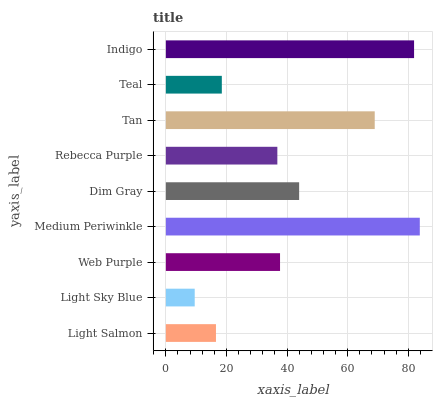Is Light Sky Blue the minimum?
Answer yes or no. Yes. Is Medium Periwinkle the maximum?
Answer yes or no. Yes. Is Web Purple the minimum?
Answer yes or no. No. Is Web Purple the maximum?
Answer yes or no. No. Is Web Purple greater than Light Sky Blue?
Answer yes or no. Yes. Is Light Sky Blue less than Web Purple?
Answer yes or no. Yes. Is Light Sky Blue greater than Web Purple?
Answer yes or no. No. Is Web Purple less than Light Sky Blue?
Answer yes or no. No. Is Web Purple the high median?
Answer yes or no. Yes. Is Web Purple the low median?
Answer yes or no. Yes. Is Indigo the high median?
Answer yes or no. No. Is Teal the low median?
Answer yes or no. No. 